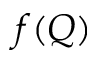Convert formula to latex. <formula><loc_0><loc_0><loc_500><loc_500>f ( Q )</formula> 